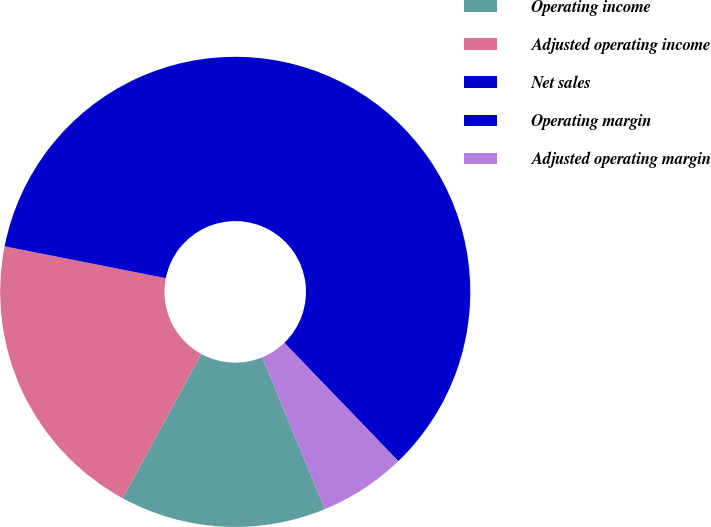Convert chart to OTSL. <chart><loc_0><loc_0><loc_500><loc_500><pie_chart><fcel>Operating income<fcel>Adjusted operating income<fcel>Net sales<fcel>Operating margin<fcel>Adjusted operating margin<nl><fcel>14.18%<fcel>20.15%<fcel>59.69%<fcel>0.0%<fcel>5.97%<nl></chart> 